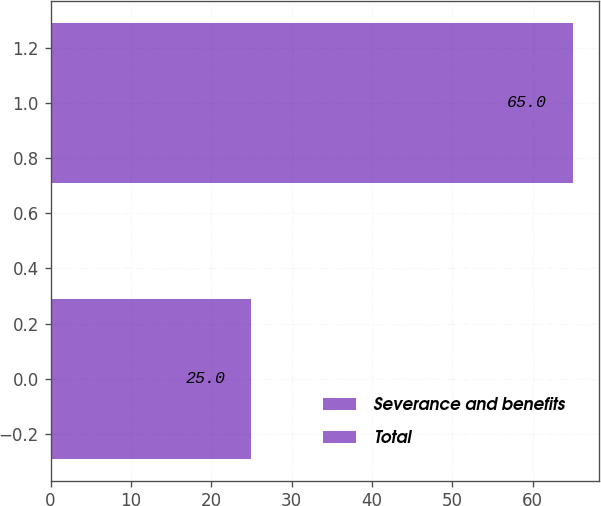Convert chart to OTSL. <chart><loc_0><loc_0><loc_500><loc_500><bar_chart><fcel>Severance and benefits<fcel>Total<nl><fcel>25<fcel>65<nl></chart> 